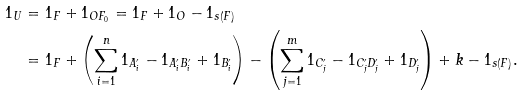<formula> <loc_0><loc_0><loc_500><loc_500>1 _ { U } & = 1 _ { F } + 1 _ { O F _ { 0 } } = 1 _ { F } + 1 _ { O } - 1 _ { s ( F ) } \\ & = 1 _ { F } + \left ( \sum _ { i = 1 } ^ { n } 1 _ { A ^ { \prime } _ { i } } - 1 _ { A ^ { \prime } _ { i } B ^ { \prime } _ { i } } + 1 _ { B ^ { \prime } _ { i } } \right ) - \left ( \sum _ { j = 1 } ^ { m } 1 _ { C ^ { \prime } _ { j } } - 1 _ { C ^ { \prime } _ { j } D ^ { \prime } _ { j } } + 1 _ { D ^ { \prime } _ { j } } \right ) + k - 1 _ { s ( F ) } .</formula> 